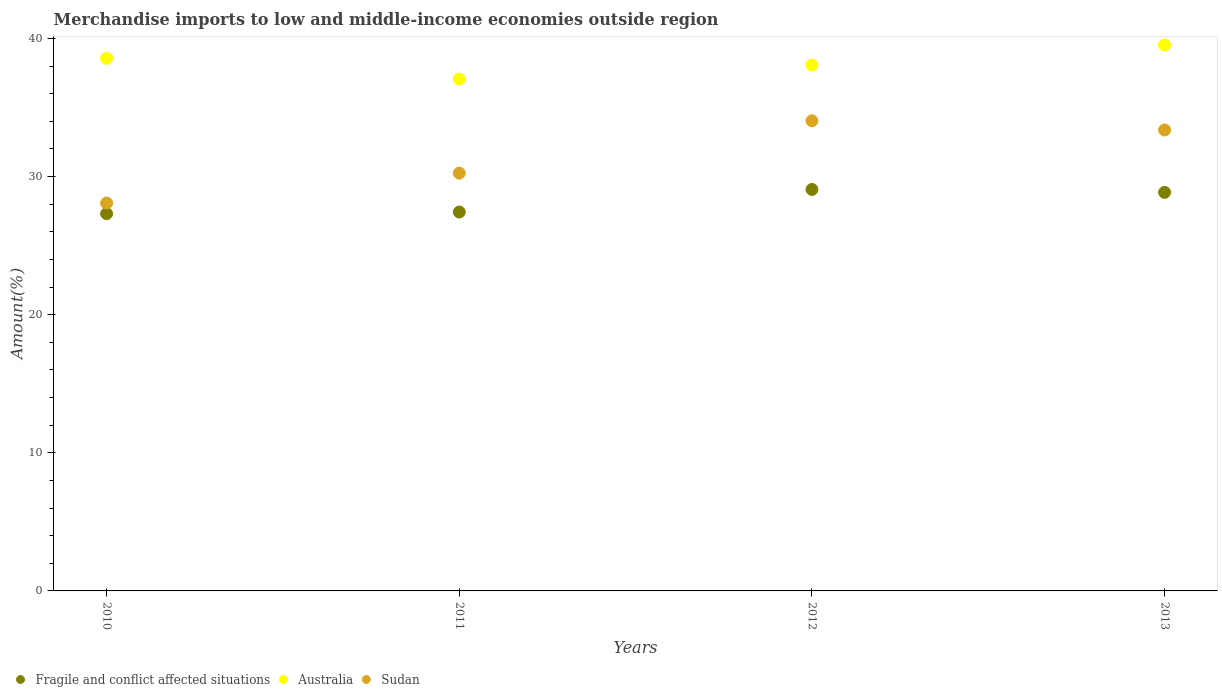How many different coloured dotlines are there?
Provide a short and direct response. 3. What is the percentage of amount earned from merchandise imports in Sudan in 2013?
Keep it short and to the point. 33.37. Across all years, what is the maximum percentage of amount earned from merchandise imports in Sudan?
Provide a short and direct response. 34.04. Across all years, what is the minimum percentage of amount earned from merchandise imports in Fragile and conflict affected situations?
Give a very brief answer. 27.32. In which year was the percentage of amount earned from merchandise imports in Fragile and conflict affected situations minimum?
Provide a short and direct response. 2010. What is the total percentage of amount earned from merchandise imports in Fragile and conflict affected situations in the graph?
Provide a short and direct response. 112.67. What is the difference between the percentage of amount earned from merchandise imports in Australia in 2012 and that in 2013?
Offer a very short reply. -1.45. What is the difference between the percentage of amount earned from merchandise imports in Fragile and conflict affected situations in 2011 and the percentage of amount earned from merchandise imports in Sudan in 2013?
Make the answer very short. -5.94. What is the average percentage of amount earned from merchandise imports in Australia per year?
Your answer should be compact. 38.31. In the year 2010, what is the difference between the percentage of amount earned from merchandise imports in Australia and percentage of amount earned from merchandise imports in Fragile and conflict affected situations?
Your response must be concise. 11.24. In how many years, is the percentage of amount earned from merchandise imports in Australia greater than 12 %?
Keep it short and to the point. 4. What is the ratio of the percentage of amount earned from merchandise imports in Fragile and conflict affected situations in 2010 to that in 2012?
Offer a terse response. 0.94. Is the percentage of amount earned from merchandise imports in Australia in 2010 less than that in 2013?
Ensure brevity in your answer.  Yes. What is the difference between the highest and the second highest percentage of amount earned from merchandise imports in Sudan?
Your response must be concise. 0.67. What is the difference between the highest and the lowest percentage of amount earned from merchandise imports in Sudan?
Ensure brevity in your answer.  5.95. In how many years, is the percentage of amount earned from merchandise imports in Australia greater than the average percentage of amount earned from merchandise imports in Australia taken over all years?
Give a very brief answer. 2. Is it the case that in every year, the sum of the percentage of amount earned from merchandise imports in Sudan and percentage of amount earned from merchandise imports in Australia  is greater than the percentage of amount earned from merchandise imports in Fragile and conflict affected situations?
Offer a very short reply. Yes. Does the percentage of amount earned from merchandise imports in Fragile and conflict affected situations monotonically increase over the years?
Offer a very short reply. No. How many years are there in the graph?
Ensure brevity in your answer.  4. Are the values on the major ticks of Y-axis written in scientific E-notation?
Provide a succinct answer. No. Does the graph contain any zero values?
Provide a short and direct response. No. Where does the legend appear in the graph?
Your response must be concise. Bottom left. How many legend labels are there?
Provide a short and direct response. 3. What is the title of the graph?
Your response must be concise. Merchandise imports to low and middle-income economies outside region. Does "Morocco" appear as one of the legend labels in the graph?
Offer a very short reply. No. What is the label or title of the Y-axis?
Your answer should be compact. Amount(%). What is the Amount(%) of Fragile and conflict affected situations in 2010?
Your answer should be compact. 27.32. What is the Amount(%) of Australia in 2010?
Your answer should be very brief. 38.56. What is the Amount(%) in Sudan in 2010?
Your answer should be very brief. 28.08. What is the Amount(%) in Fragile and conflict affected situations in 2011?
Your response must be concise. 27.43. What is the Amount(%) of Australia in 2011?
Your response must be concise. 37.06. What is the Amount(%) of Sudan in 2011?
Offer a terse response. 30.25. What is the Amount(%) in Fragile and conflict affected situations in 2012?
Give a very brief answer. 29.07. What is the Amount(%) in Australia in 2012?
Keep it short and to the point. 38.08. What is the Amount(%) of Sudan in 2012?
Offer a terse response. 34.04. What is the Amount(%) of Fragile and conflict affected situations in 2013?
Give a very brief answer. 28.85. What is the Amount(%) of Australia in 2013?
Provide a succinct answer. 39.52. What is the Amount(%) of Sudan in 2013?
Your answer should be very brief. 33.37. Across all years, what is the maximum Amount(%) in Fragile and conflict affected situations?
Offer a terse response. 29.07. Across all years, what is the maximum Amount(%) of Australia?
Provide a succinct answer. 39.52. Across all years, what is the maximum Amount(%) of Sudan?
Your response must be concise. 34.04. Across all years, what is the minimum Amount(%) of Fragile and conflict affected situations?
Offer a very short reply. 27.32. Across all years, what is the minimum Amount(%) in Australia?
Your answer should be very brief. 37.06. Across all years, what is the minimum Amount(%) in Sudan?
Keep it short and to the point. 28.08. What is the total Amount(%) in Fragile and conflict affected situations in the graph?
Offer a very short reply. 112.67. What is the total Amount(%) of Australia in the graph?
Your answer should be compact. 153.22. What is the total Amount(%) in Sudan in the graph?
Make the answer very short. 125.74. What is the difference between the Amount(%) in Fragile and conflict affected situations in 2010 and that in 2011?
Make the answer very short. -0.12. What is the difference between the Amount(%) in Australia in 2010 and that in 2011?
Make the answer very short. 1.5. What is the difference between the Amount(%) in Sudan in 2010 and that in 2011?
Provide a succinct answer. -2.17. What is the difference between the Amount(%) of Fragile and conflict affected situations in 2010 and that in 2012?
Make the answer very short. -1.75. What is the difference between the Amount(%) of Australia in 2010 and that in 2012?
Keep it short and to the point. 0.48. What is the difference between the Amount(%) of Sudan in 2010 and that in 2012?
Offer a very short reply. -5.96. What is the difference between the Amount(%) of Fragile and conflict affected situations in 2010 and that in 2013?
Provide a succinct answer. -1.54. What is the difference between the Amount(%) of Australia in 2010 and that in 2013?
Ensure brevity in your answer.  -0.96. What is the difference between the Amount(%) in Sudan in 2010 and that in 2013?
Make the answer very short. -5.29. What is the difference between the Amount(%) of Fragile and conflict affected situations in 2011 and that in 2012?
Offer a very short reply. -1.64. What is the difference between the Amount(%) of Australia in 2011 and that in 2012?
Give a very brief answer. -1.02. What is the difference between the Amount(%) of Sudan in 2011 and that in 2012?
Provide a short and direct response. -3.79. What is the difference between the Amount(%) in Fragile and conflict affected situations in 2011 and that in 2013?
Offer a terse response. -1.42. What is the difference between the Amount(%) of Australia in 2011 and that in 2013?
Ensure brevity in your answer.  -2.46. What is the difference between the Amount(%) in Sudan in 2011 and that in 2013?
Make the answer very short. -3.12. What is the difference between the Amount(%) in Fragile and conflict affected situations in 2012 and that in 2013?
Your response must be concise. 0.21. What is the difference between the Amount(%) in Australia in 2012 and that in 2013?
Offer a very short reply. -1.45. What is the difference between the Amount(%) in Sudan in 2012 and that in 2013?
Your answer should be very brief. 0.67. What is the difference between the Amount(%) in Fragile and conflict affected situations in 2010 and the Amount(%) in Australia in 2011?
Provide a short and direct response. -9.74. What is the difference between the Amount(%) in Fragile and conflict affected situations in 2010 and the Amount(%) in Sudan in 2011?
Offer a very short reply. -2.93. What is the difference between the Amount(%) in Australia in 2010 and the Amount(%) in Sudan in 2011?
Provide a short and direct response. 8.31. What is the difference between the Amount(%) of Fragile and conflict affected situations in 2010 and the Amount(%) of Australia in 2012?
Your response must be concise. -10.76. What is the difference between the Amount(%) in Fragile and conflict affected situations in 2010 and the Amount(%) in Sudan in 2012?
Your answer should be compact. -6.72. What is the difference between the Amount(%) of Australia in 2010 and the Amount(%) of Sudan in 2012?
Offer a very short reply. 4.52. What is the difference between the Amount(%) of Fragile and conflict affected situations in 2010 and the Amount(%) of Australia in 2013?
Provide a succinct answer. -12.21. What is the difference between the Amount(%) of Fragile and conflict affected situations in 2010 and the Amount(%) of Sudan in 2013?
Keep it short and to the point. -6.06. What is the difference between the Amount(%) of Australia in 2010 and the Amount(%) of Sudan in 2013?
Your answer should be very brief. 5.19. What is the difference between the Amount(%) of Fragile and conflict affected situations in 2011 and the Amount(%) of Australia in 2012?
Offer a terse response. -10.65. What is the difference between the Amount(%) in Fragile and conflict affected situations in 2011 and the Amount(%) in Sudan in 2012?
Offer a terse response. -6.61. What is the difference between the Amount(%) in Australia in 2011 and the Amount(%) in Sudan in 2012?
Ensure brevity in your answer.  3.02. What is the difference between the Amount(%) in Fragile and conflict affected situations in 2011 and the Amount(%) in Australia in 2013?
Offer a terse response. -12.09. What is the difference between the Amount(%) in Fragile and conflict affected situations in 2011 and the Amount(%) in Sudan in 2013?
Your response must be concise. -5.94. What is the difference between the Amount(%) in Australia in 2011 and the Amount(%) in Sudan in 2013?
Your answer should be very brief. 3.69. What is the difference between the Amount(%) of Fragile and conflict affected situations in 2012 and the Amount(%) of Australia in 2013?
Your answer should be very brief. -10.46. What is the difference between the Amount(%) in Fragile and conflict affected situations in 2012 and the Amount(%) in Sudan in 2013?
Your answer should be very brief. -4.3. What is the difference between the Amount(%) in Australia in 2012 and the Amount(%) in Sudan in 2013?
Provide a short and direct response. 4.71. What is the average Amount(%) of Fragile and conflict affected situations per year?
Keep it short and to the point. 28.17. What is the average Amount(%) of Australia per year?
Provide a succinct answer. 38.31. What is the average Amount(%) in Sudan per year?
Provide a succinct answer. 31.43. In the year 2010, what is the difference between the Amount(%) of Fragile and conflict affected situations and Amount(%) of Australia?
Give a very brief answer. -11.24. In the year 2010, what is the difference between the Amount(%) in Fragile and conflict affected situations and Amount(%) in Sudan?
Give a very brief answer. -0.77. In the year 2010, what is the difference between the Amount(%) in Australia and Amount(%) in Sudan?
Make the answer very short. 10.48. In the year 2011, what is the difference between the Amount(%) of Fragile and conflict affected situations and Amount(%) of Australia?
Offer a very short reply. -9.63. In the year 2011, what is the difference between the Amount(%) in Fragile and conflict affected situations and Amount(%) in Sudan?
Your answer should be very brief. -2.82. In the year 2011, what is the difference between the Amount(%) in Australia and Amount(%) in Sudan?
Your answer should be very brief. 6.81. In the year 2012, what is the difference between the Amount(%) in Fragile and conflict affected situations and Amount(%) in Australia?
Your answer should be compact. -9.01. In the year 2012, what is the difference between the Amount(%) of Fragile and conflict affected situations and Amount(%) of Sudan?
Make the answer very short. -4.97. In the year 2012, what is the difference between the Amount(%) in Australia and Amount(%) in Sudan?
Provide a succinct answer. 4.04. In the year 2013, what is the difference between the Amount(%) of Fragile and conflict affected situations and Amount(%) of Australia?
Keep it short and to the point. -10.67. In the year 2013, what is the difference between the Amount(%) in Fragile and conflict affected situations and Amount(%) in Sudan?
Give a very brief answer. -4.52. In the year 2013, what is the difference between the Amount(%) in Australia and Amount(%) in Sudan?
Provide a succinct answer. 6.15. What is the ratio of the Amount(%) of Fragile and conflict affected situations in 2010 to that in 2011?
Give a very brief answer. 1. What is the ratio of the Amount(%) in Australia in 2010 to that in 2011?
Ensure brevity in your answer.  1.04. What is the ratio of the Amount(%) in Sudan in 2010 to that in 2011?
Your response must be concise. 0.93. What is the ratio of the Amount(%) in Fragile and conflict affected situations in 2010 to that in 2012?
Offer a terse response. 0.94. What is the ratio of the Amount(%) of Australia in 2010 to that in 2012?
Give a very brief answer. 1.01. What is the ratio of the Amount(%) of Sudan in 2010 to that in 2012?
Your response must be concise. 0.82. What is the ratio of the Amount(%) in Fragile and conflict affected situations in 2010 to that in 2013?
Make the answer very short. 0.95. What is the ratio of the Amount(%) in Australia in 2010 to that in 2013?
Your answer should be very brief. 0.98. What is the ratio of the Amount(%) of Sudan in 2010 to that in 2013?
Keep it short and to the point. 0.84. What is the ratio of the Amount(%) in Fragile and conflict affected situations in 2011 to that in 2012?
Offer a very short reply. 0.94. What is the ratio of the Amount(%) of Australia in 2011 to that in 2012?
Provide a short and direct response. 0.97. What is the ratio of the Amount(%) in Sudan in 2011 to that in 2012?
Provide a short and direct response. 0.89. What is the ratio of the Amount(%) in Fragile and conflict affected situations in 2011 to that in 2013?
Provide a succinct answer. 0.95. What is the ratio of the Amount(%) in Australia in 2011 to that in 2013?
Offer a very short reply. 0.94. What is the ratio of the Amount(%) in Sudan in 2011 to that in 2013?
Provide a succinct answer. 0.91. What is the ratio of the Amount(%) in Fragile and conflict affected situations in 2012 to that in 2013?
Offer a terse response. 1.01. What is the ratio of the Amount(%) in Australia in 2012 to that in 2013?
Offer a very short reply. 0.96. What is the ratio of the Amount(%) of Sudan in 2012 to that in 2013?
Provide a succinct answer. 1.02. What is the difference between the highest and the second highest Amount(%) of Fragile and conflict affected situations?
Keep it short and to the point. 0.21. What is the difference between the highest and the second highest Amount(%) in Australia?
Provide a succinct answer. 0.96. What is the difference between the highest and the second highest Amount(%) of Sudan?
Keep it short and to the point. 0.67. What is the difference between the highest and the lowest Amount(%) of Fragile and conflict affected situations?
Give a very brief answer. 1.75. What is the difference between the highest and the lowest Amount(%) in Australia?
Provide a short and direct response. 2.46. What is the difference between the highest and the lowest Amount(%) of Sudan?
Make the answer very short. 5.96. 